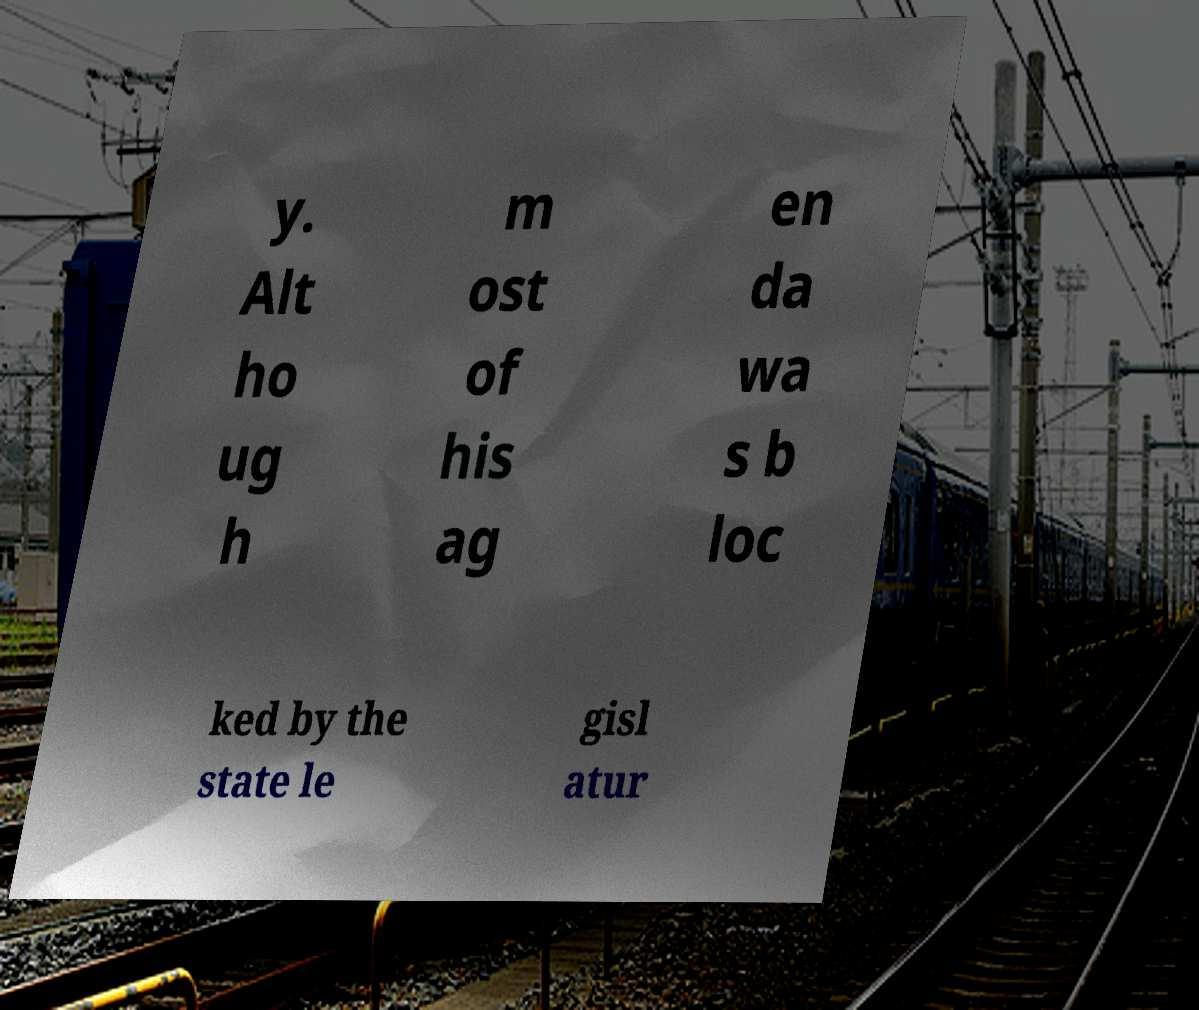For documentation purposes, I need the text within this image transcribed. Could you provide that? y. Alt ho ug h m ost of his ag en da wa s b loc ked by the state le gisl atur 